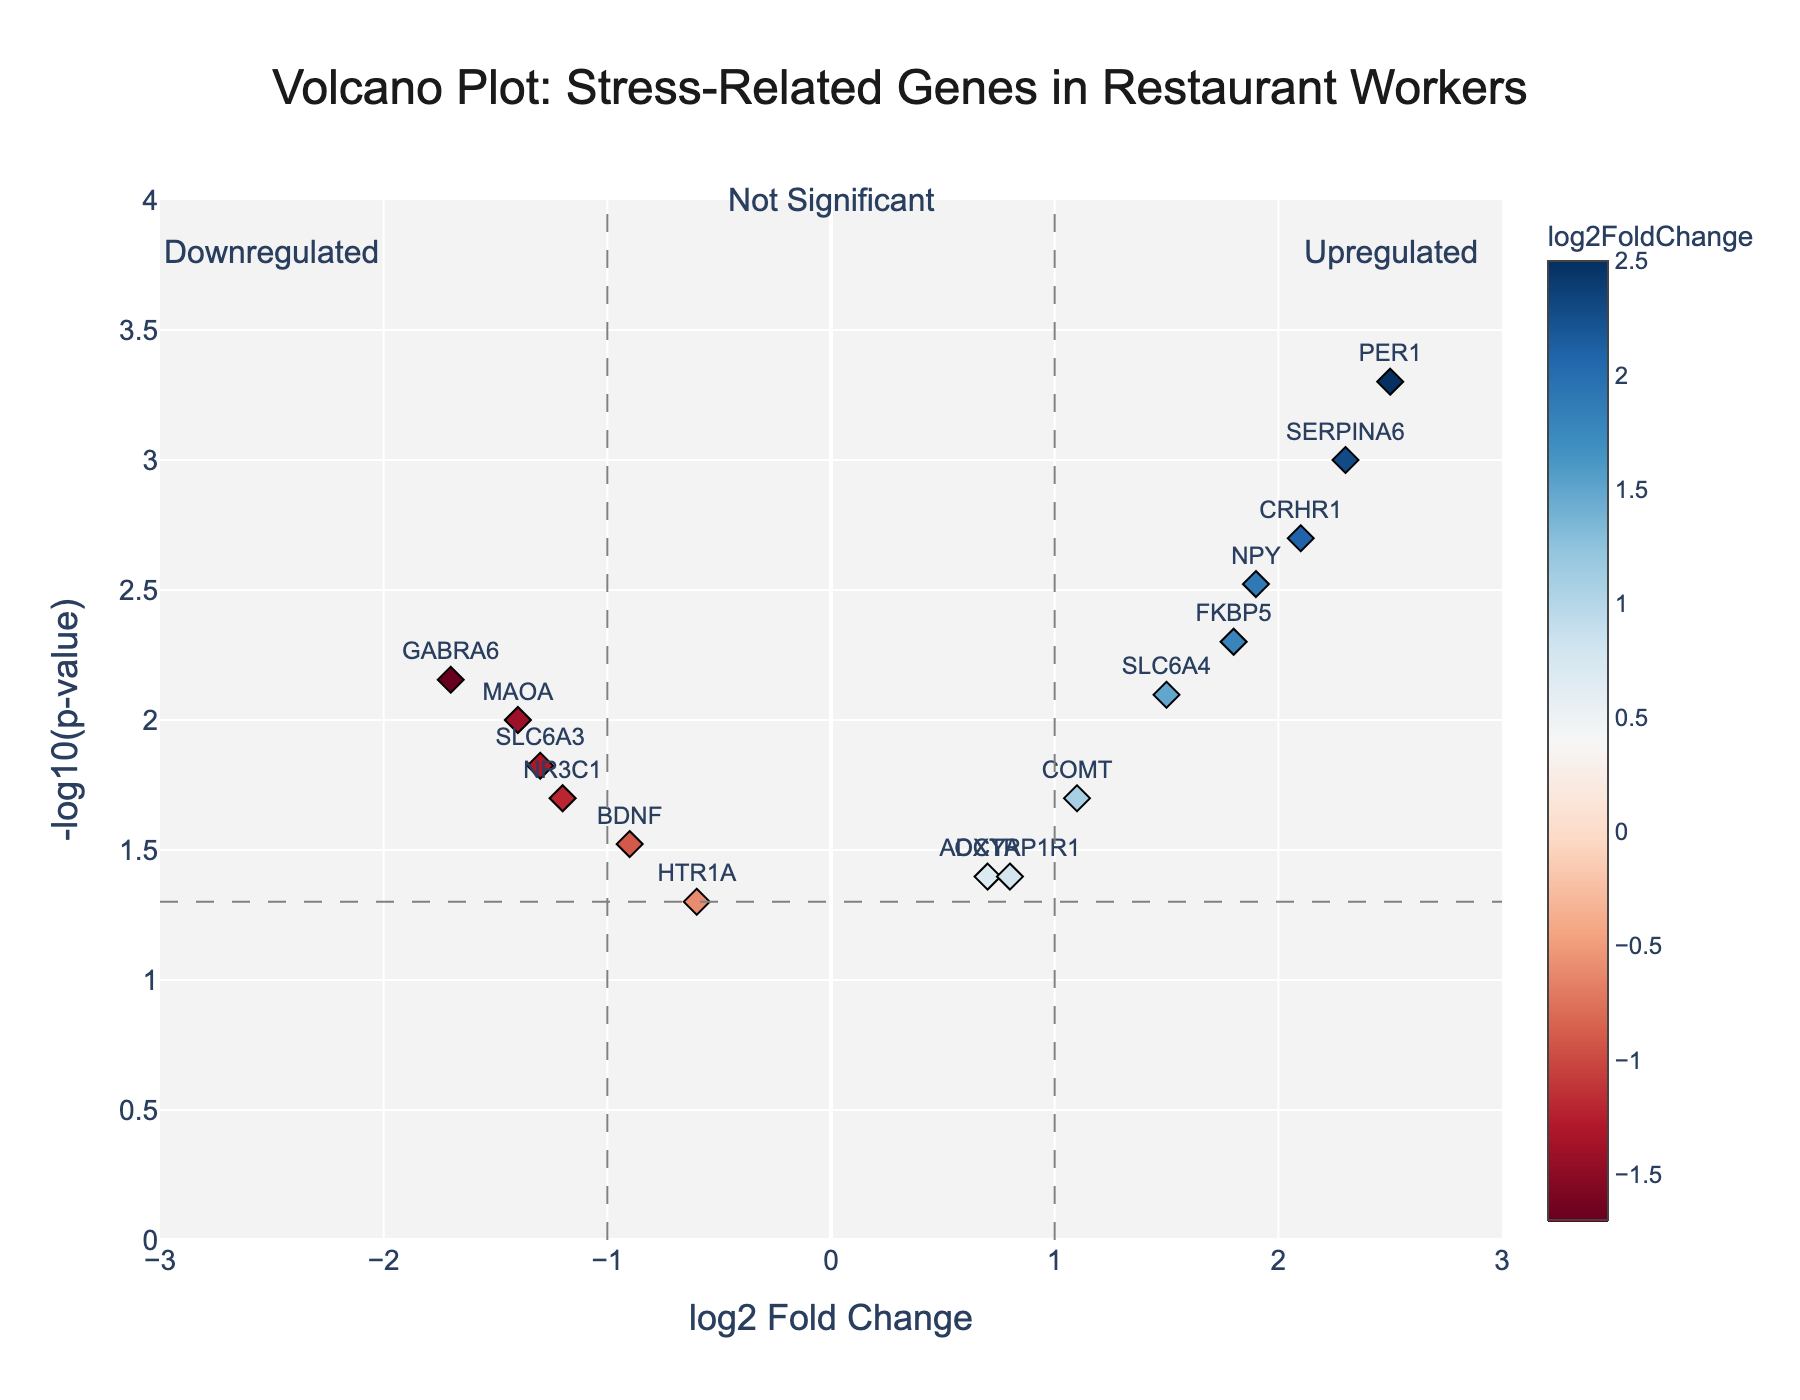How many genes are upregulated during peak hours? Upregulated genes are those with a positive log2FoldChange and significant p-values. Looking at the right side of the plot, we count the labeled points with positive log2FoldChange values and significant p-values (high on the y-axis).
Answer: 9 Which gene shows the highest level of upregulation? The highest level of upregulation corresponds to the highest positive log2FoldChange value. From the plot, the gene PER1 is at the top with the highest log2FoldChange around 2.5.
Answer: PER1 Are there more upregulated or downregulated genes? Count the number of upregulated (positive log2FoldChange) and downregulated (negative log2FoldChange) genes from the plot.
Answer: More upregulated What is the significance cutoff for the p-value? The significance cutoff line for the p-value in the volcano plot is typically drawn at -log10(p-value) = 1.3. This corresponds to a p-value of 0.05, as indicated by the dashed horizontal line.
Answer: 0.05 Which gene has the lowest p-value among the downregulated genes? Among the downregulated genes (negative log2FoldChange), the one highest on the y-axis (where -log10(p-value) is highest) is GABRA6.
Answer: GABRA6 What does the color of the points represent in the plot? The color bar indicates that a gradient color scale is used to represent the log2FoldChange values. Points with higher log2FoldChange values are displayed in warm colors, and those with lower or negative values in cool colors.
Answer: log2FoldChange How many genes have a log2FoldChange value greater than 1 and a p-value less than 0.01? From the plot, we identify genes with log2FoldChange > 1 and check if these points are above the y-axis threshold line corresponding to -log10(0.01). The identified genes are SERPINA6, CRHR1, PER1, and NPY.
Answer: 4 Which gene has a log2FoldChange closest to 0 but still significant? The gene with a log2FoldChange closest to 0 but with a high -log10(p-value) is OXTR located near the log2FoldChange 0 line but above the significance threshold.
Answer: OXTR What does the dashed vertical lines at -1 and 1 log2FoldChange indicate? These lines typically indicate thresholds for considering significant upregulation (log2FoldChange > 1) and downregulation (log2FoldChange < -1), visually categorizing genes into three groups of regulation.
Answer: Thresholds for significance Is there any gene with both a significant high fold change and a p-value less than 0.001? The gene with significant high fold change and very low p-value is PER1, as it is far right and high on the y-axis.
Answer: PER1 